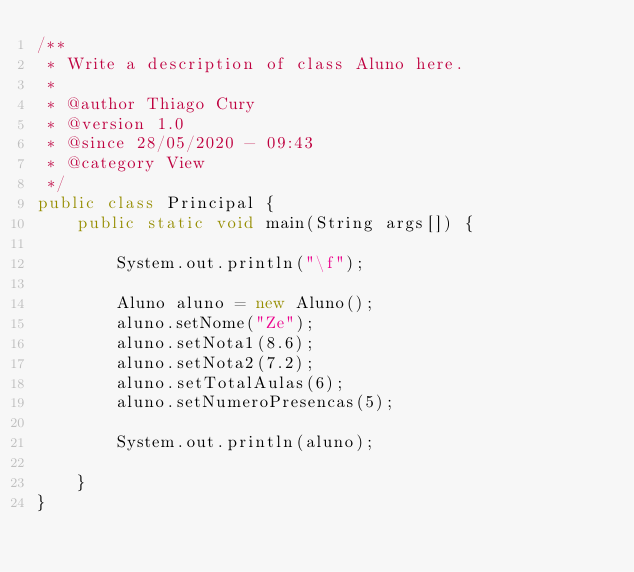<code> <loc_0><loc_0><loc_500><loc_500><_Java_>/**
 * Write a description of class Aluno here.
 *
 * @author Thiago Cury
 * @version 1.0
 * @since 28/05/2020 - 09:43
 * @category View
 */
public class Principal {
    public static void main(String args[]) {
    
        System.out.println("\f");
        
        Aluno aluno = new Aluno();
        aluno.setNome("Ze");
        aluno.setNota1(8.6);
        aluno.setNota2(7.2);
        aluno.setTotalAulas(6);
        aluno.setNumeroPresencas(5);
        
        System.out.println(aluno);
        
    }
}
</code> 